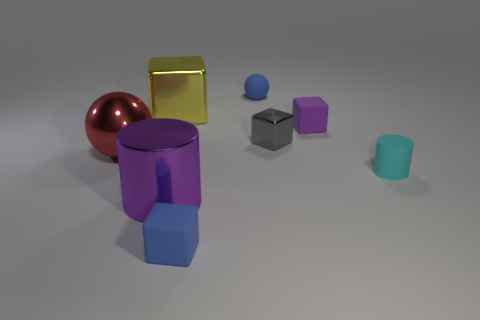Subtract all cyan cylinders. Subtract all red cubes. How many cylinders are left? 1 Add 1 gray things. How many objects exist? 9 Subtract all big things. Subtract all purple objects. How many objects are left? 3 Add 4 tiny cyan things. How many tiny cyan things are left? 5 Add 4 tiny purple matte things. How many tiny purple matte things exist? 5 Subtract 1 purple cylinders. How many objects are left? 7 